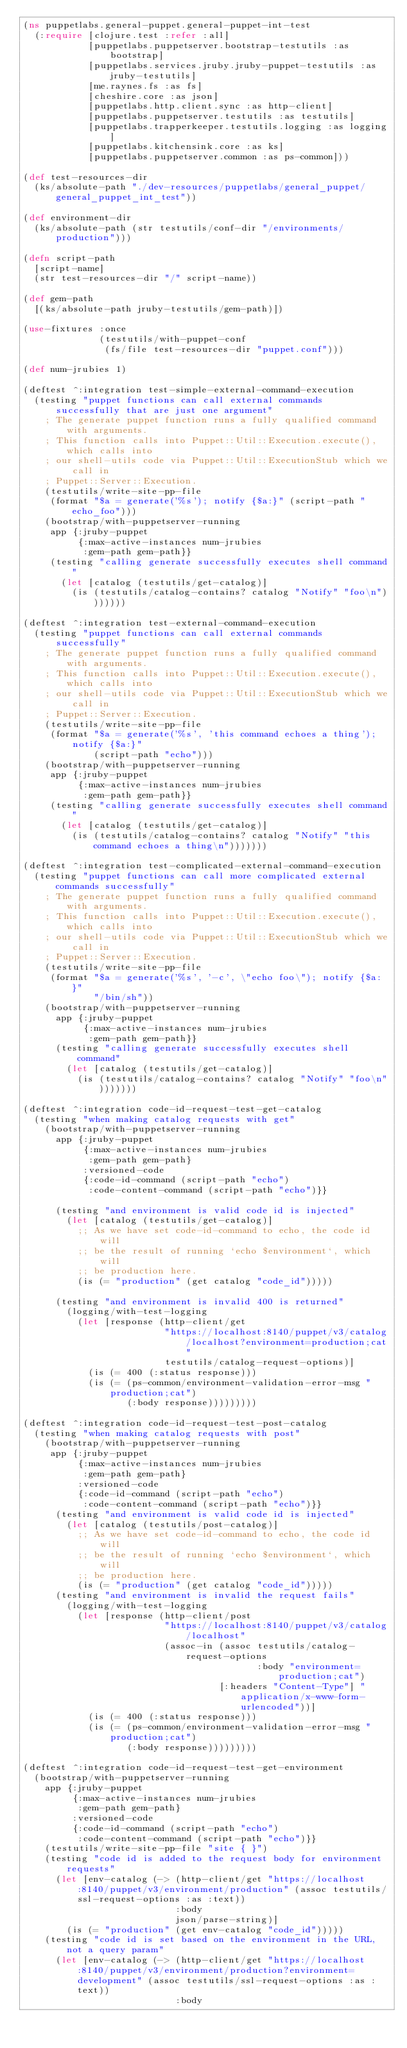<code> <loc_0><loc_0><loc_500><loc_500><_Clojure_>(ns puppetlabs.general-puppet.general-puppet-int-test
  (:require [clojure.test :refer :all]
            [puppetlabs.puppetserver.bootstrap-testutils :as bootstrap]
            [puppetlabs.services.jruby.jruby-puppet-testutils :as jruby-testutils]
            [me.raynes.fs :as fs]
            [cheshire.core :as json]
            [puppetlabs.http.client.sync :as http-client]
            [puppetlabs.puppetserver.testutils :as testutils]
            [puppetlabs.trapperkeeper.testutils.logging :as logging]
            [puppetlabs.kitchensink.core :as ks]
            [puppetlabs.puppetserver.common :as ps-common]))

(def test-resources-dir
  (ks/absolute-path "./dev-resources/puppetlabs/general_puppet/general_puppet_int_test"))

(def environment-dir
  (ks/absolute-path (str testutils/conf-dir "/environments/production")))

(defn script-path
  [script-name]
  (str test-resources-dir "/" script-name))

(def gem-path
  [(ks/absolute-path jruby-testutils/gem-path)])

(use-fixtures :once
              (testutils/with-puppet-conf
               (fs/file test-resources-dir "puppet.conf")))

(def num-jrubies 1)

(deftest ^:integration test-simple-external-command-execution
  (testing "puppet functions can call external commands successfully that are just one argument"
    ; The generate puppet function runs a fully qualified command with arguments.
    ; This function calls into Puppet::Util::Execution.execute(), which calls into
    ; our shell-utils code via Puppet::Util::ExecutionStub which we call in
    ; Puppet::Server::Execution.
    (testutils/write-site-pp-file
     (format "$a = generate('%s'); notify {$a:}" (script-path "echo_foo")))
    (bootstrap/with-puppetserver-running
     app {:jruby-puppet
          {:max-active-instances num-jrubies
           :gem-path gem-path}}
     (testing "calling generate successfully executes shell command"
       (let [catalog (testutils/get-catalog)]
         (is (testutils/catalog-contains? catalog "Notify" "foo\n")))))))

(deftest ^:integration test-external-command-execution
  (testing "puppet functions can call external commands successfully"
    ; The generate puppet function runs a fully qualified command with arguments.
    ; This function calls into Puppet::Util::Execution.execute(), which calls into
    ; our shell-utils code via Puppet::Util::ExecutionStub which we call in
    ; Puppet::Server::Execution.
    (testutils/write-site-pp-file
     (format "$a = generate('%s', 'this command echoes a thing'); notify {$a:}"
             (script-path "echo")))
    (bootstrap/with-puppetserver-running
     app {:jruby-puppet
          {:max-active-instances num-jrubies
           :gem-path gem-path}}
     (testing "calling generate successfully executes shell command"
       (let [catalog (testutils/get-catalog)]
         (is (testutils/catalog-contains? catalog "Notify" "this command echoes a thing\n")))))))

(deftest ^:integration test-complicated-external-command-execution
  (testing "puppet functions can call more complicated external commands successfully"
    ; The generate puppet function runs a fully qualified command with arguments.
    ; This function calls into Puppet::Util::Execution.execute(), which calls into
    ; our shell-utils code via Puppet::Util::ExecutionStub which we call in
    ; Puppet::Server::Execution.
    (testutils/write-site-pp-file
     (format "$a = generate('%s', '-c', \"echo foo\"); notify {$a: }"
             "/bin/sh"))
    (bootstrap/with-puppetserver-running
      app {:jruby-puppet
           {:max-active-instances num-jrubies
            :gem-path gem-path}}
      (testing "calling generate successfully executes shell command"
        (let [catalog (testutils/get-catalog)]
          (is (testutils/catalog-contains? catalog "Notify" "foo\n")))))))

(deftest ^:integration code-id-request-test-get-catalog
  (testing "when making catalog requests with get"
    (bootstrap/with-puppetserver-running
      app {:jruby-puppet
           {:max-active-instances num-jrubies
            :gem-path gem-path}
           :versioned-code
           {:code-id-command (script-path "echo")
            :code-content-command (script-path "echo")}}

      (testing "and environment is valid code id is injected"
        (let [catalog (testutils/get-catalog)]
          ;; As we have set code-id-command to echo, the code id will
          ;; be the result of running `echo $environment`, which will
          ;; be production here.
          (is (= "production" (get catalog "code_id")))))

      (testing "and environment is invalid 400 is returned"
        (logging/with-test-logging
          (let [response (http-client/get
                          "https://localhost:8140/puppet/v3/catalog/localhost?environment=production;cat"
                          testutils/catalog-request-options)]
            (is (= 400 (:status response)))
            (is (= (ps-common/environment-validation-error-msg "production;cat")
                   (:body response)))))))))

(deftest ^:integration code-id-request-test-post-catalog
  (testing "when making catalog requests with post"
    (bootstrap/with-puppetserver-running
     app {:jruby-puppet
          {:max-active-instances num-jrubies
           :gem-path gem-path}
          :versioned-code
          {:code-id-command (script-path "echo")
           :code-content-command (script-path "echo")}}
      (testing "and environment is valid code id is injected"
        (let [catalog (testutils/post-catalog)]
          ;; As we have set code-id-command to echo, the code id will
          ;; be the result of running `echo $environment`, which will
          ;; be production here.
          (is (= "production" (get catalog "code_id")))))
      (testing "and environment is invalid the request fails"
        (logging/with-test-logging
          (let [response (http-client/post
                          "https://localhost:8140/puppet/v3/catalog/localhost"
                          (assoc-in (assoc testutils/catalog-request-options
                                           :body "environment=production;cat")
                                    [:headers "Content-Type"] "application/x-www-form-urlencoded"))]
            (is (= 400 (:status response)))
            (is (= (ps-common/environment-validation-error-msg "production;cat")
                   (:body response)))))))))

(deftest ^:integration code-id-request-test-get-environment
  (bootstrap/with-puppetserver-running
    app {:jruby-puppet
         {:max-active-instances num-jrubies
          :gem-path gem-path}
         :versioned-code
         {:code-id-command (script-path "echo")
          :code-content-command (script-path "echo")}}
    (testutils/write-site-pp-file "site { }")
    (testing "code id is added to the request body for environment requests"
      (let [env-catalog (-> (http-client/get "https://localhost:8140/puppet/v3/environment/production" (assoc testutils/ssl-request-options :as :text))
                            :body
                            json/parse-string)]
        (is (= "production" (get env-catalog "code_id")))))
    (testing "code id is set based on the environment in the URL, not a query param"
      (let [env-catalog (-> (http-client/get "https://localhost:8140/puppet/v3/environment/production?environment=development" (assoc testutils/ssl-request-options :as :text))
                            :body</code> 